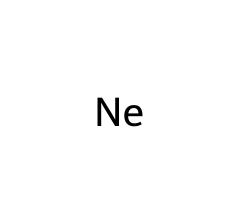What is the atomic number of neon? Neon is represented by the symbol "Ne" and has an atomic number of 10, which is well-known among noble gases.
Answer: 10 How many electrons does neon have? Since neon's atomic number is 10, it also has 10 electrons because, in a neutral atom, the number of electrons equals the atomic number.
Answer: 10 What group of the periodic table does neon belong to? Neon is a noble gas, which is located in Group 18 of the periodic table.
Answer: Group 18 Is neon reactive or inert? Neon is classified as a noble gas, known for being inert and non-reactive under standard conditions due to its complete valence shell.
Answer: Inert What is the common use of neon in advertising? Neon is commonly used in illuminated signs, particularly for creating bright neon lights that are visually striking in political campaign contexts.
Answer: Illuminated signs What is the electron configuration of neon? Neon has the electron configuration of 1s² 2s² 2p⁶, which indicates a filled outer shell, characteristic of stable noble gases.
Answer: 1s² 2s² 2p⁶ How many valence electrons does neon have? Neon has 8 valence electrons as it is in Group 18, which is significant for its stability and inert nature.
Answer: 8 